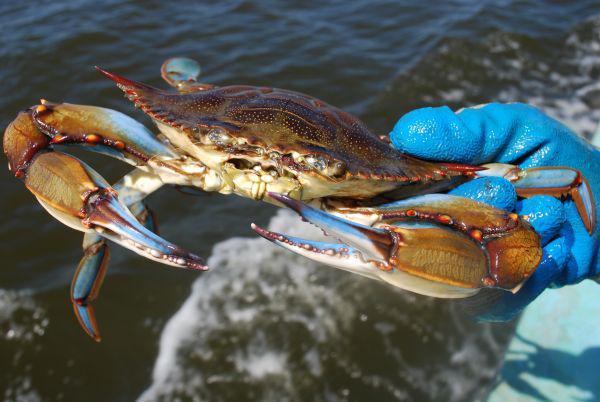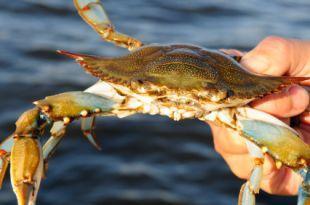The first image is the image on the left, the second image is the image on the right. For the images displayed, is the sentence "Each image includes a forward-facing crab, and in one image, a crab is held by a bare hand." factually correct? Answer yes or no. Yes. The first image is the image on the left, the second image is the image on the right. Analyze the images presented: Is the assertion "In at least one image there is an ungloved hand holding a live crab." valid? Answer yes or no. Yes. 